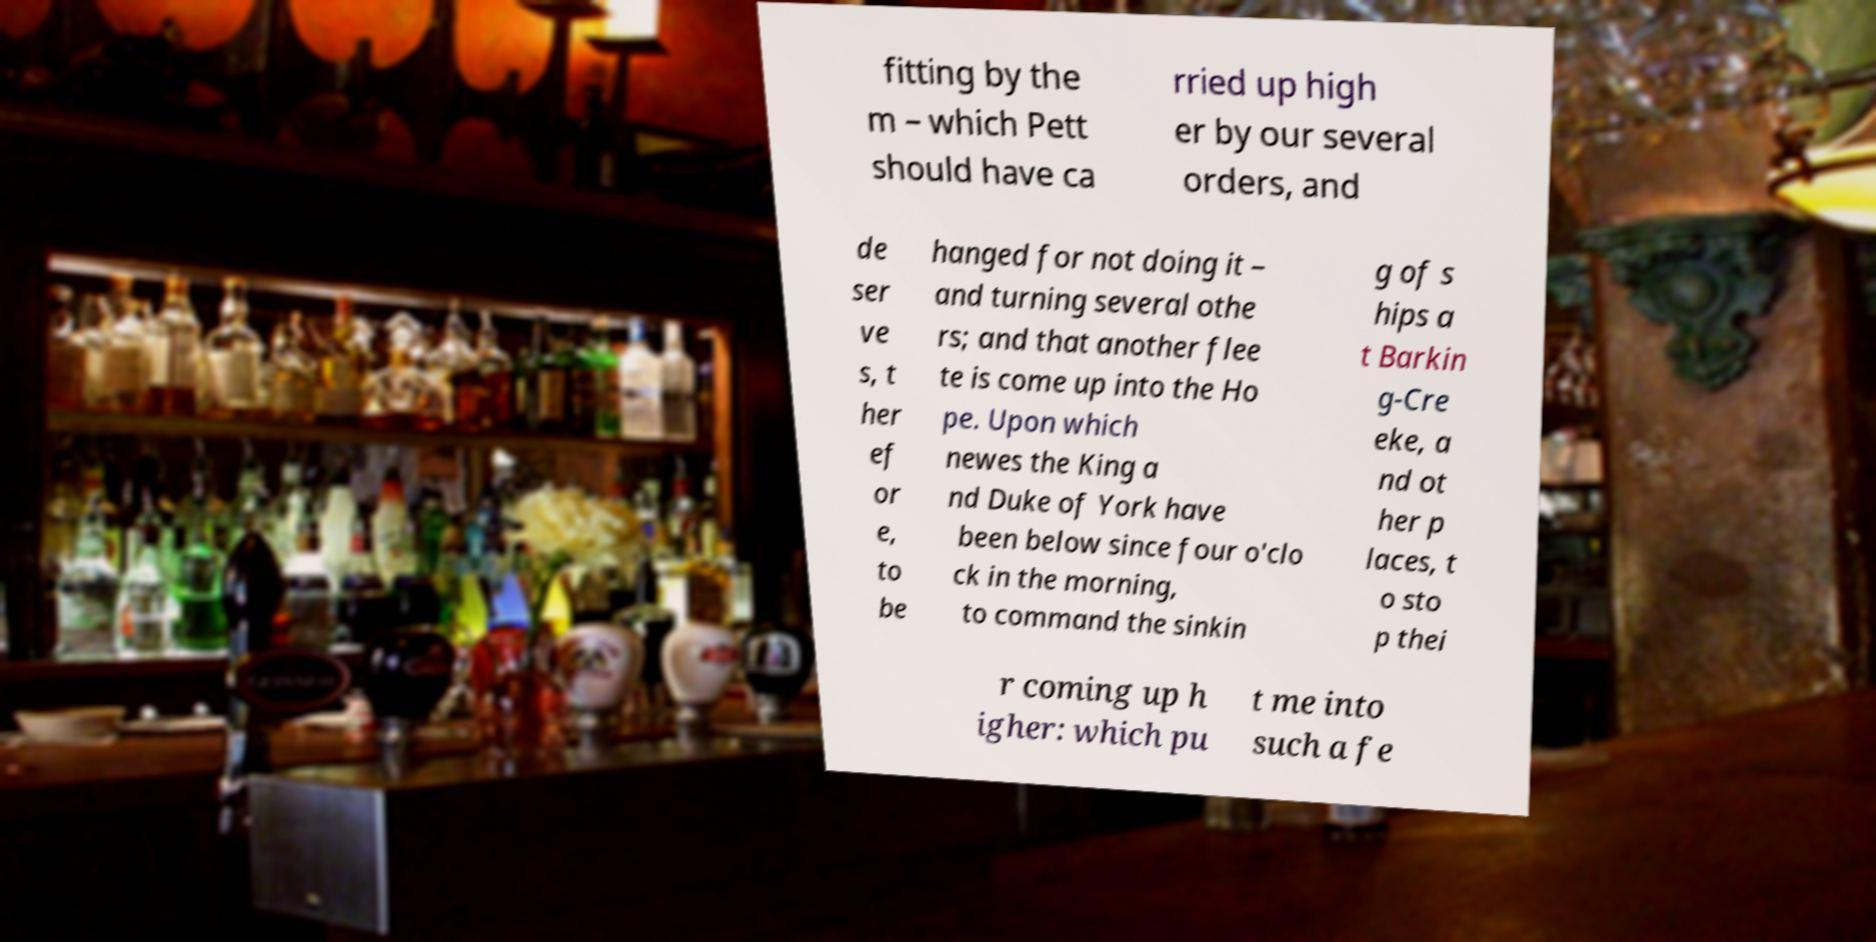Can you accurately transcribe the text from the provided image for me? fitting by the m – which Pett should have ca rried up high er by our several orders, and de ser ve s, t her ef or e, to be hanged for not doing it – and turning several othe rs; and that another flee te is come up into the Ho pe. Upon which newes the King a nd Duke of York have been below since four o'clo ck in the morning, to command the sinkin g of s hips a t Barkin g-Cre eke, a nd ot her p laces, t o sto p thei r coming up h igher: which pu t me into such a fe 